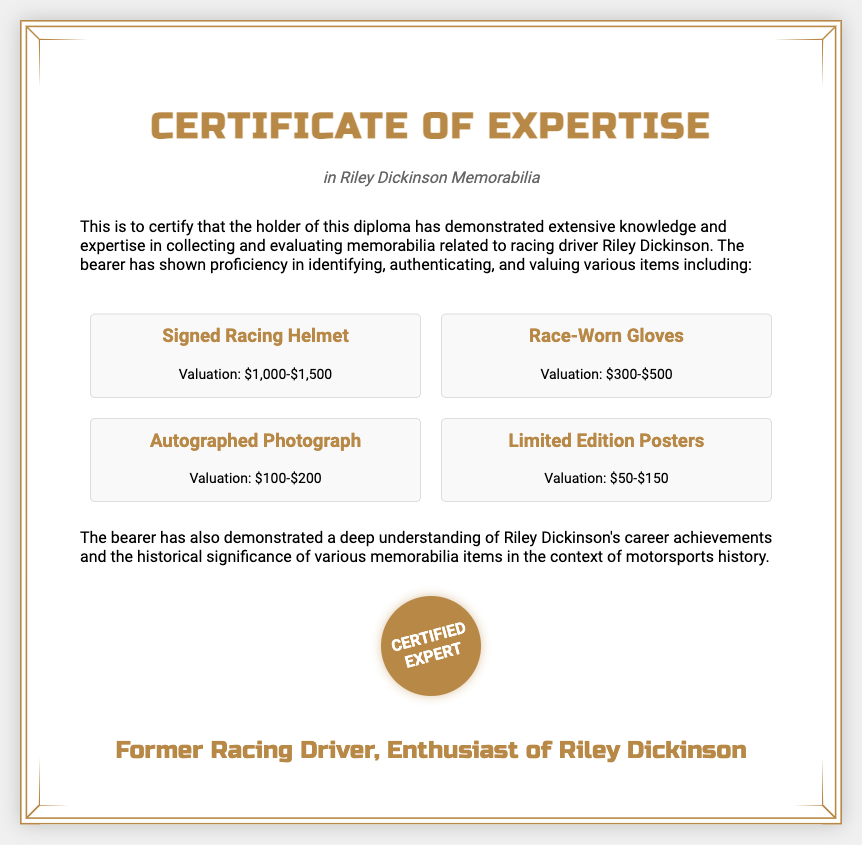What is the title of the document? The title of the document is prominently displayed at the top of the certificate.
Answer: Certificate of Expertise Who is the focus of the memorabilia discussed? The focus of the memorabilia is indicated in the subtitle of the diploma.
Answer: Riley Dickinson What is the valuation range of the signed racing helmet? The valuation range for the signed racing helmet is provided in the item section of the document.
Answer: $1,000-$1,500 What item has the lowest valuation? The lowest valuation is mentioned in the valuation details of the memorabilia items.
Answer: Limited Edition Posters What certification does the holder of this diploma receive? The certification achieved is highlighted within the content and is related to expertise in a specific area.
Answer: Certified Expert What is the profession of the individual who signed the diploma? The profession is revealed in the signature section of the certificate.
Answer: Former Racing Driver Which type of collectible item has a valuation between $100 and $200? This item’s valuation is specifically mentioned in the document, requiring inference about the valuation range.
Answer: Autographed Photograph What skill has the bearer demonstrated in the context of racing memorabilia? The skills demonstrated are outlined in the introductory content discussing the expertise of the holder.
Answer: Collecting and evaluating memorabilia 